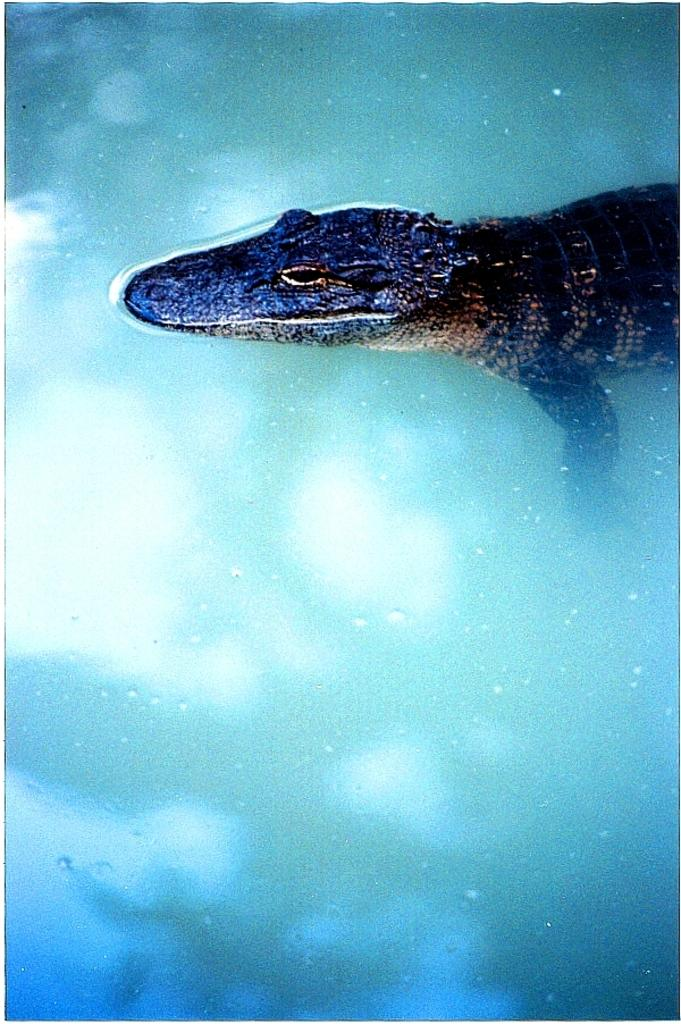What type of animal is present in the image? There is a water animal in the image. Where is the water animal located? The water animal is in water. What type of stick can be seen floating next to the water animal in the image? There is no stick present in the image; it only features a water animal in water. 